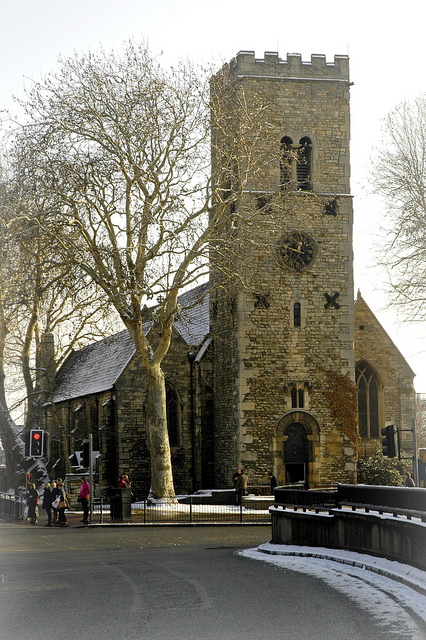<image>Where is the clock? There is no clock in the image. However, it can be on a tower or building. What is red? I am not sure what is red. It can be a traffic light or a man's shirt. What is red? The object that is red is ambiguous. It can be a traffic light, a light or a man's shirt. Where is the clock? The clock is on the tower. 